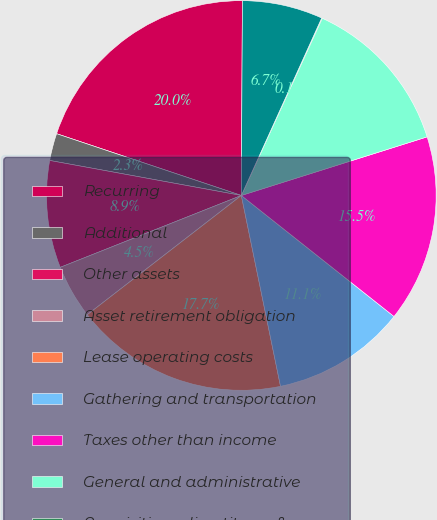<chart> <loc_0><loc_0><loc_500><loc_500><pie_chart><fcel>Recurring<fcel>Additional<fcel>Other assets<fcel>Asset retirement obligation<fcel>Lease operating costs<fcel>Gathering and transportation<fcel>Taxes other than income<fcel>General and administrative<fcel>Acquisitions divestitures &<fcel>Financing costs net<nl><fcel>19.95%<fcel>2.26%<fcel>8.89%<fcel>4.47%<fcel>17.74%<fcel>11.11%<fcel>15.53%<fcel>13.32%<fcel>0.05%<fcel>6.68%<nl></chart> 